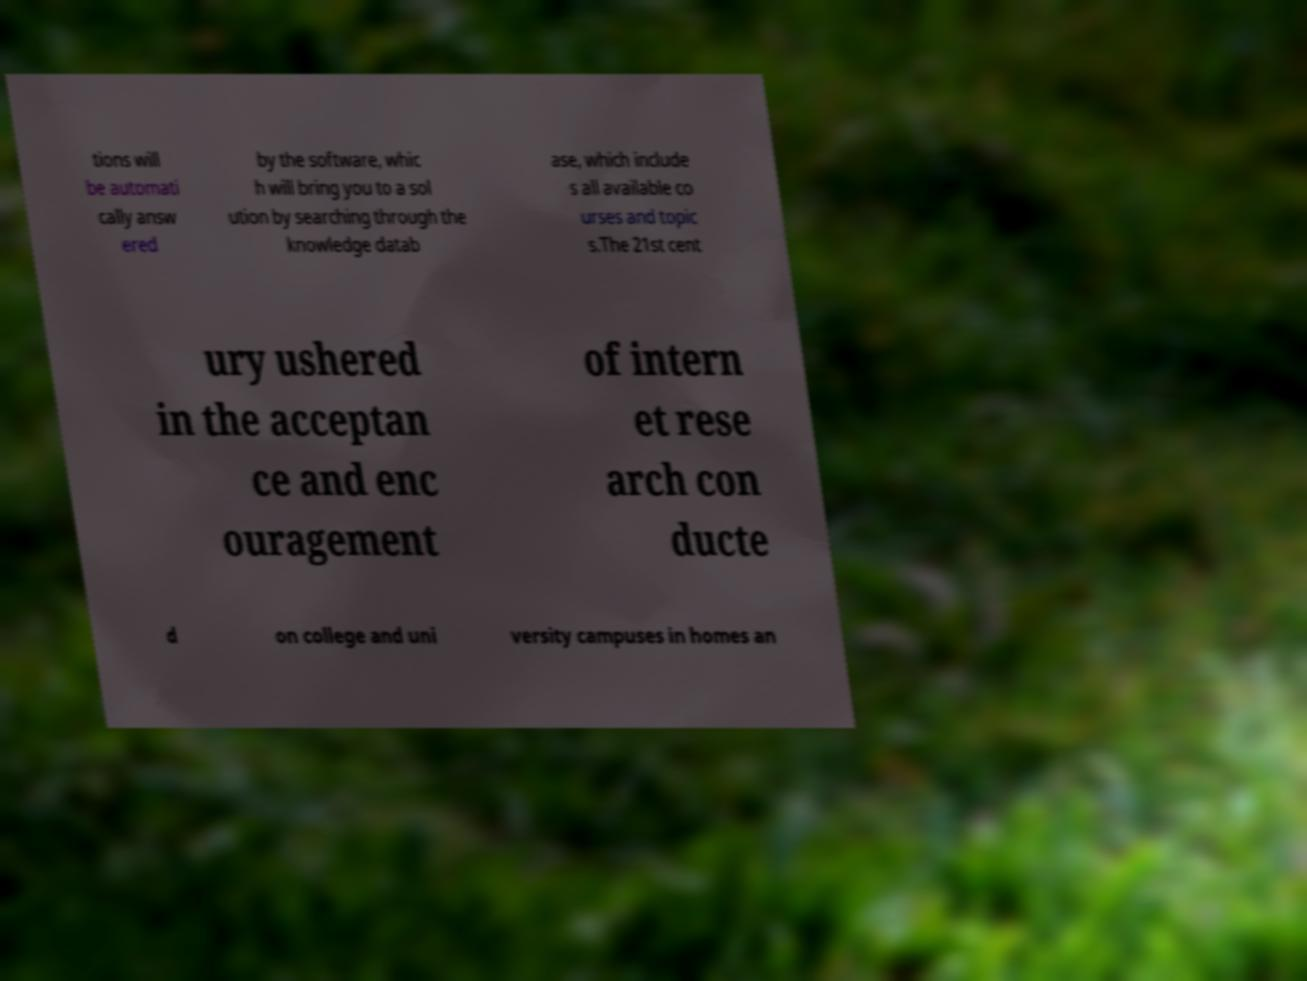What messages or text are displayed in this image? I need them in a readable, typed format. tions will be automati cally answ ered by the software, whic h will bring you to a sol ution by searching through the knowledge datab ase, which include s all available co urses and topic s.The 21st cent ury ushered in the acceptan ce and enc ouragement of intern et rese arch con ducte d on college and uni versity campuses in homes an 